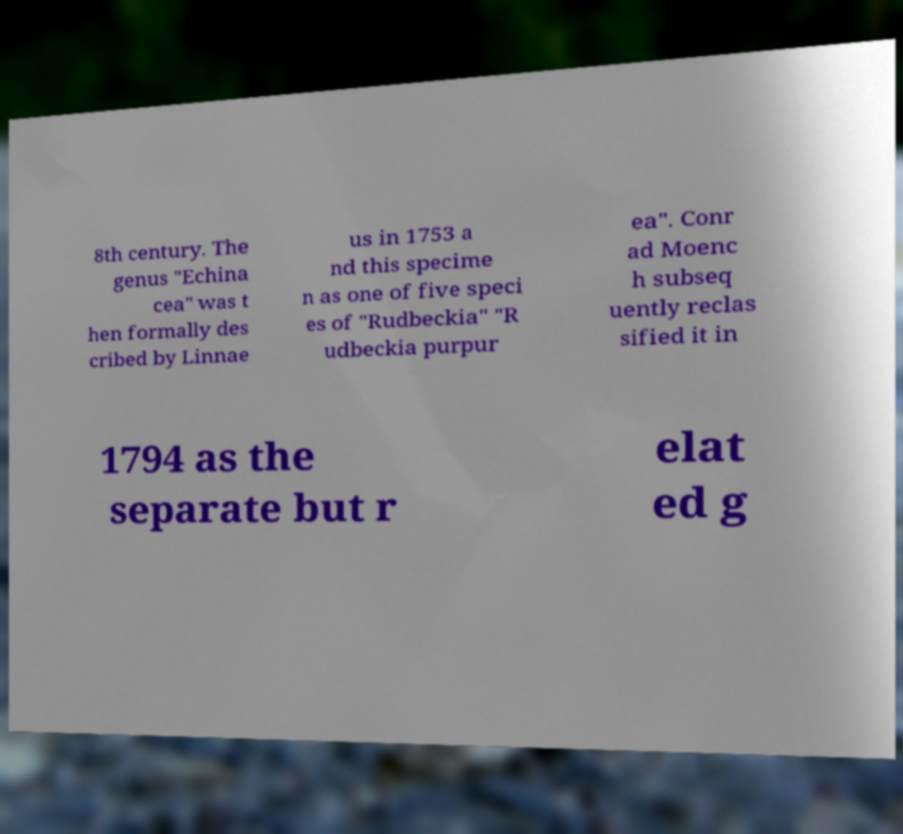Can you read and provide the text displayed in the image?This photo seems to have some interesting text. Can you extract and type it out for me? 8th century. The genus "Echina cea" was t hen formally des cribed by Linnae us in 1753 a nd this specime n as one of five speci es of "Rudbeckia" "R udbeckia purpur ea". Conr ad Moenc h subseq uently reclas sified it in 1794 as the separate but r elat ed g 